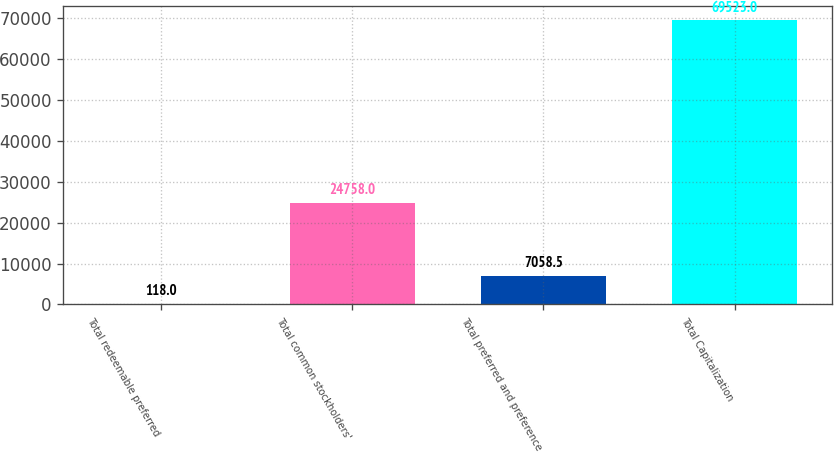<chart> <loc_0><loc_0><loc_500><loc_500><bar_chart><fcel>Total redeemable preferred<fcel>Total common stockholders'<fcel>Total preferred and preference<fcel>Total Capitalization<nl><fcel>118<fcel>24758<fcel>7058.5<fcel>69523<nl></chart> 